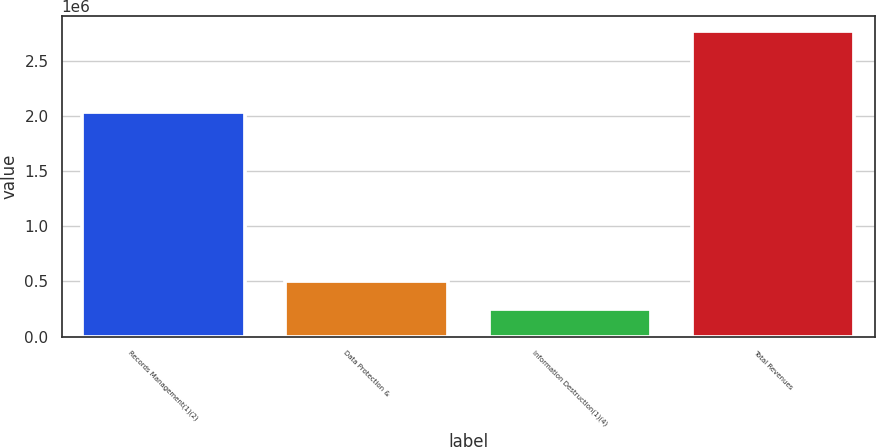<chart> <loc_0><loc_0><loc_500><loc_500><bar_chart><fcel>Records Management(1)(2)<fcel>Data Protection &<fcel>Information Destruction(1)(4)<fcel>Total Revenues<nl><fcel>2.0405e+06<fcel>502419<fcel>249978<fcel>2.77438e+06<nl></chart> 